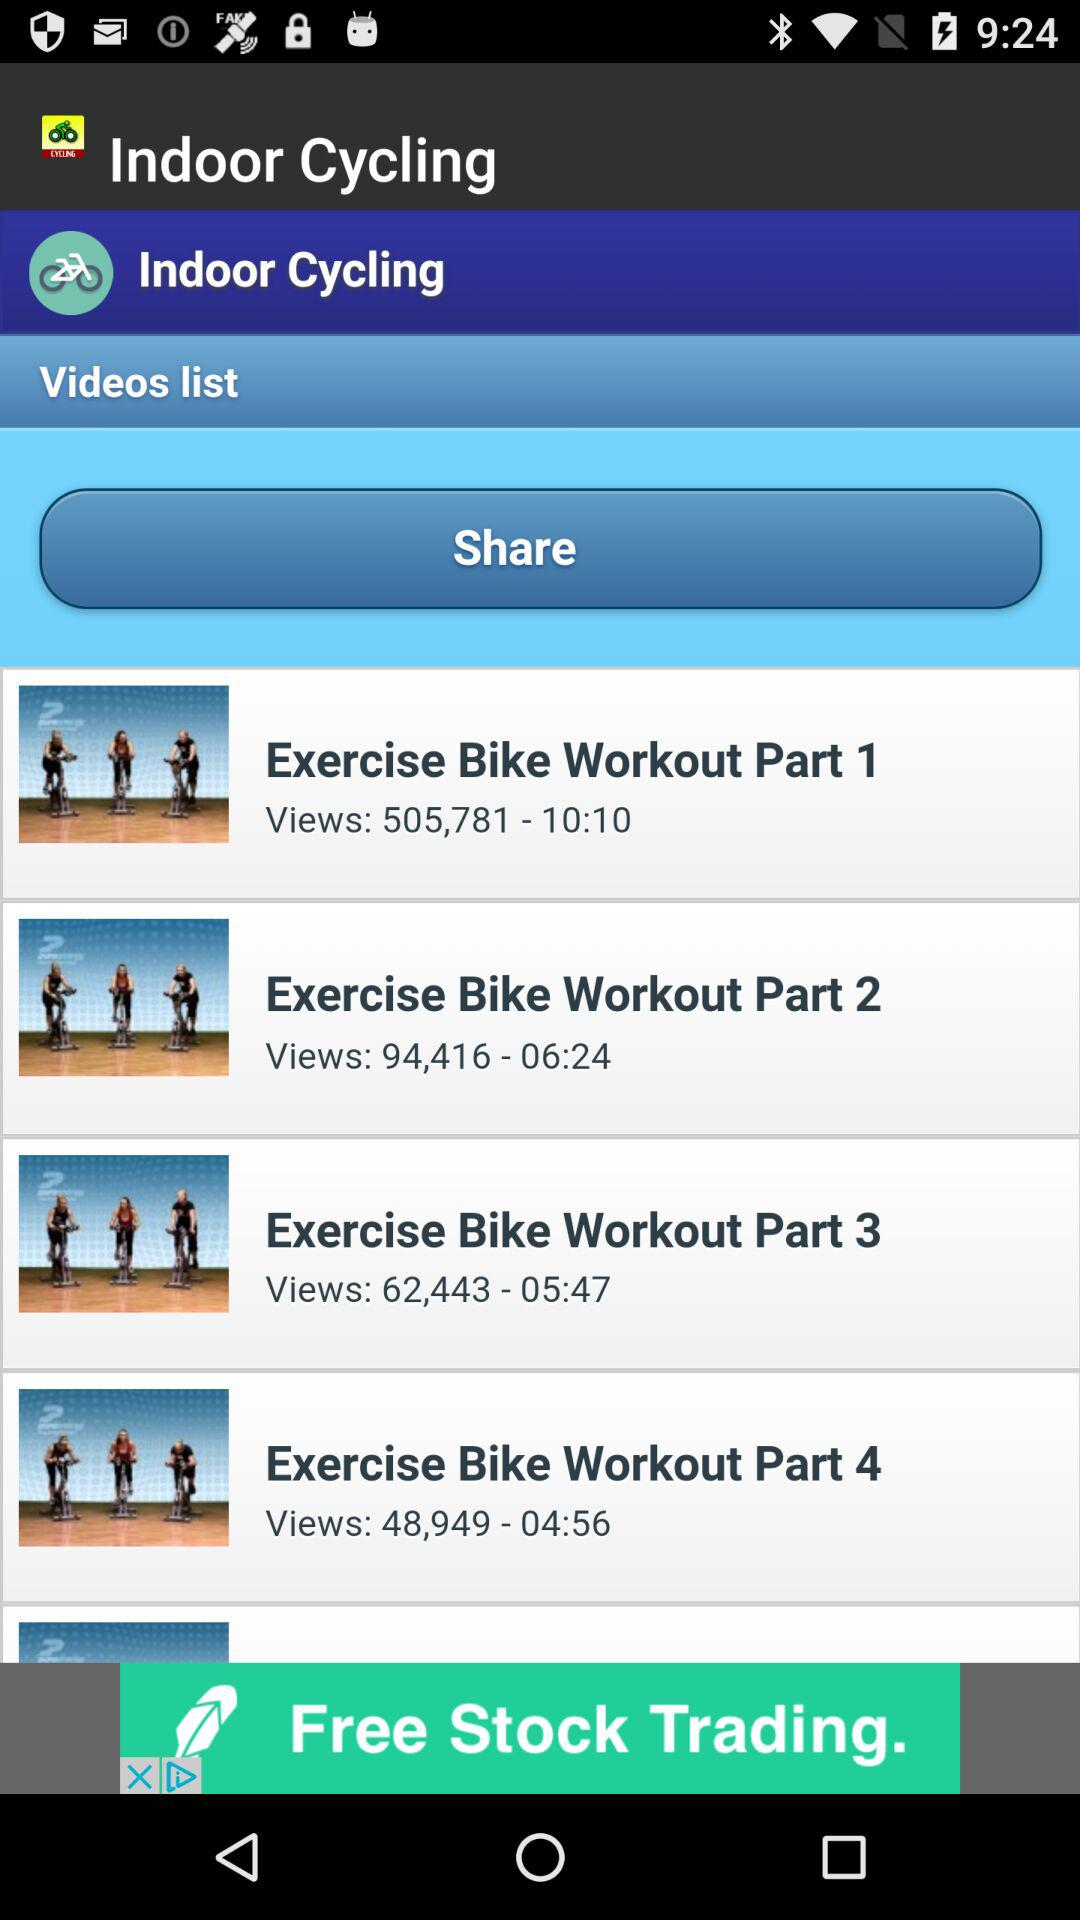How many more views does the first video have than the second video?
Answer the question using a single word or phrase. 411365 